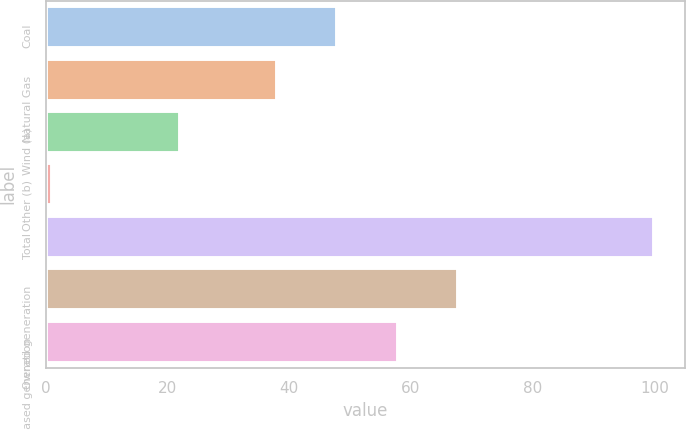Convert chart. <chart><loc_0><loc_0><loc_500><loc_500><bar_chart><fcel>Coal<fcel>Natural Gas<fcel>Wind (a)<fcel>Other (b)<fcel>Total<fcel>Owned generation<fcel>Purchased generation<nl><fcel>47.9<fcel>38<fcel>22<fcel>1<fcel>100<fcel>67.7<fcel>57.8<nl></chart> 